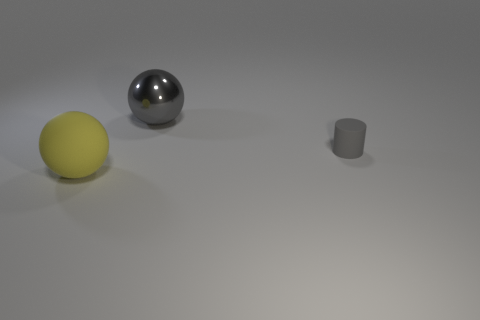Do the metallic object and the rubber object behind the yellow object have the same color?
Provide a succinct answer. Yes. What is the size of the metallic object that is the same color as the tiny cylinder?
Offer a very short reply. Large. Is the number of small gray matte cylinders to the left of the gray rubber cylinder less than the number of gray things that are to the left of the large gray metal thing?
Provide a short and direct response. No. What number of gray objects are matte spheres or big metal things?
Ensure brevity in your answer.  1. Is the number of yellow balls to the left of the large yellow ball the same as the number of red rubber cubes?
Offer a very short reply. Yes. What number of things are large yellow metallic cylinders or rubber objects right of the shiny sphere?
Provide a succinct answer. 1. Do the small matte object and the shiny sphere have the same color?
Provide a succinct answer. Yes. Is there a tiny gray thing that has the same material as the big yellow sphere?
Your answer should be very brief. Yes. What is the color of the other object that is the same shape as the big yellow object?
Your response must be concise. Gray. Are the small object and the big ball that is to the left of the metallic ball made of the same material?
Give a very brief answer. Yes. 